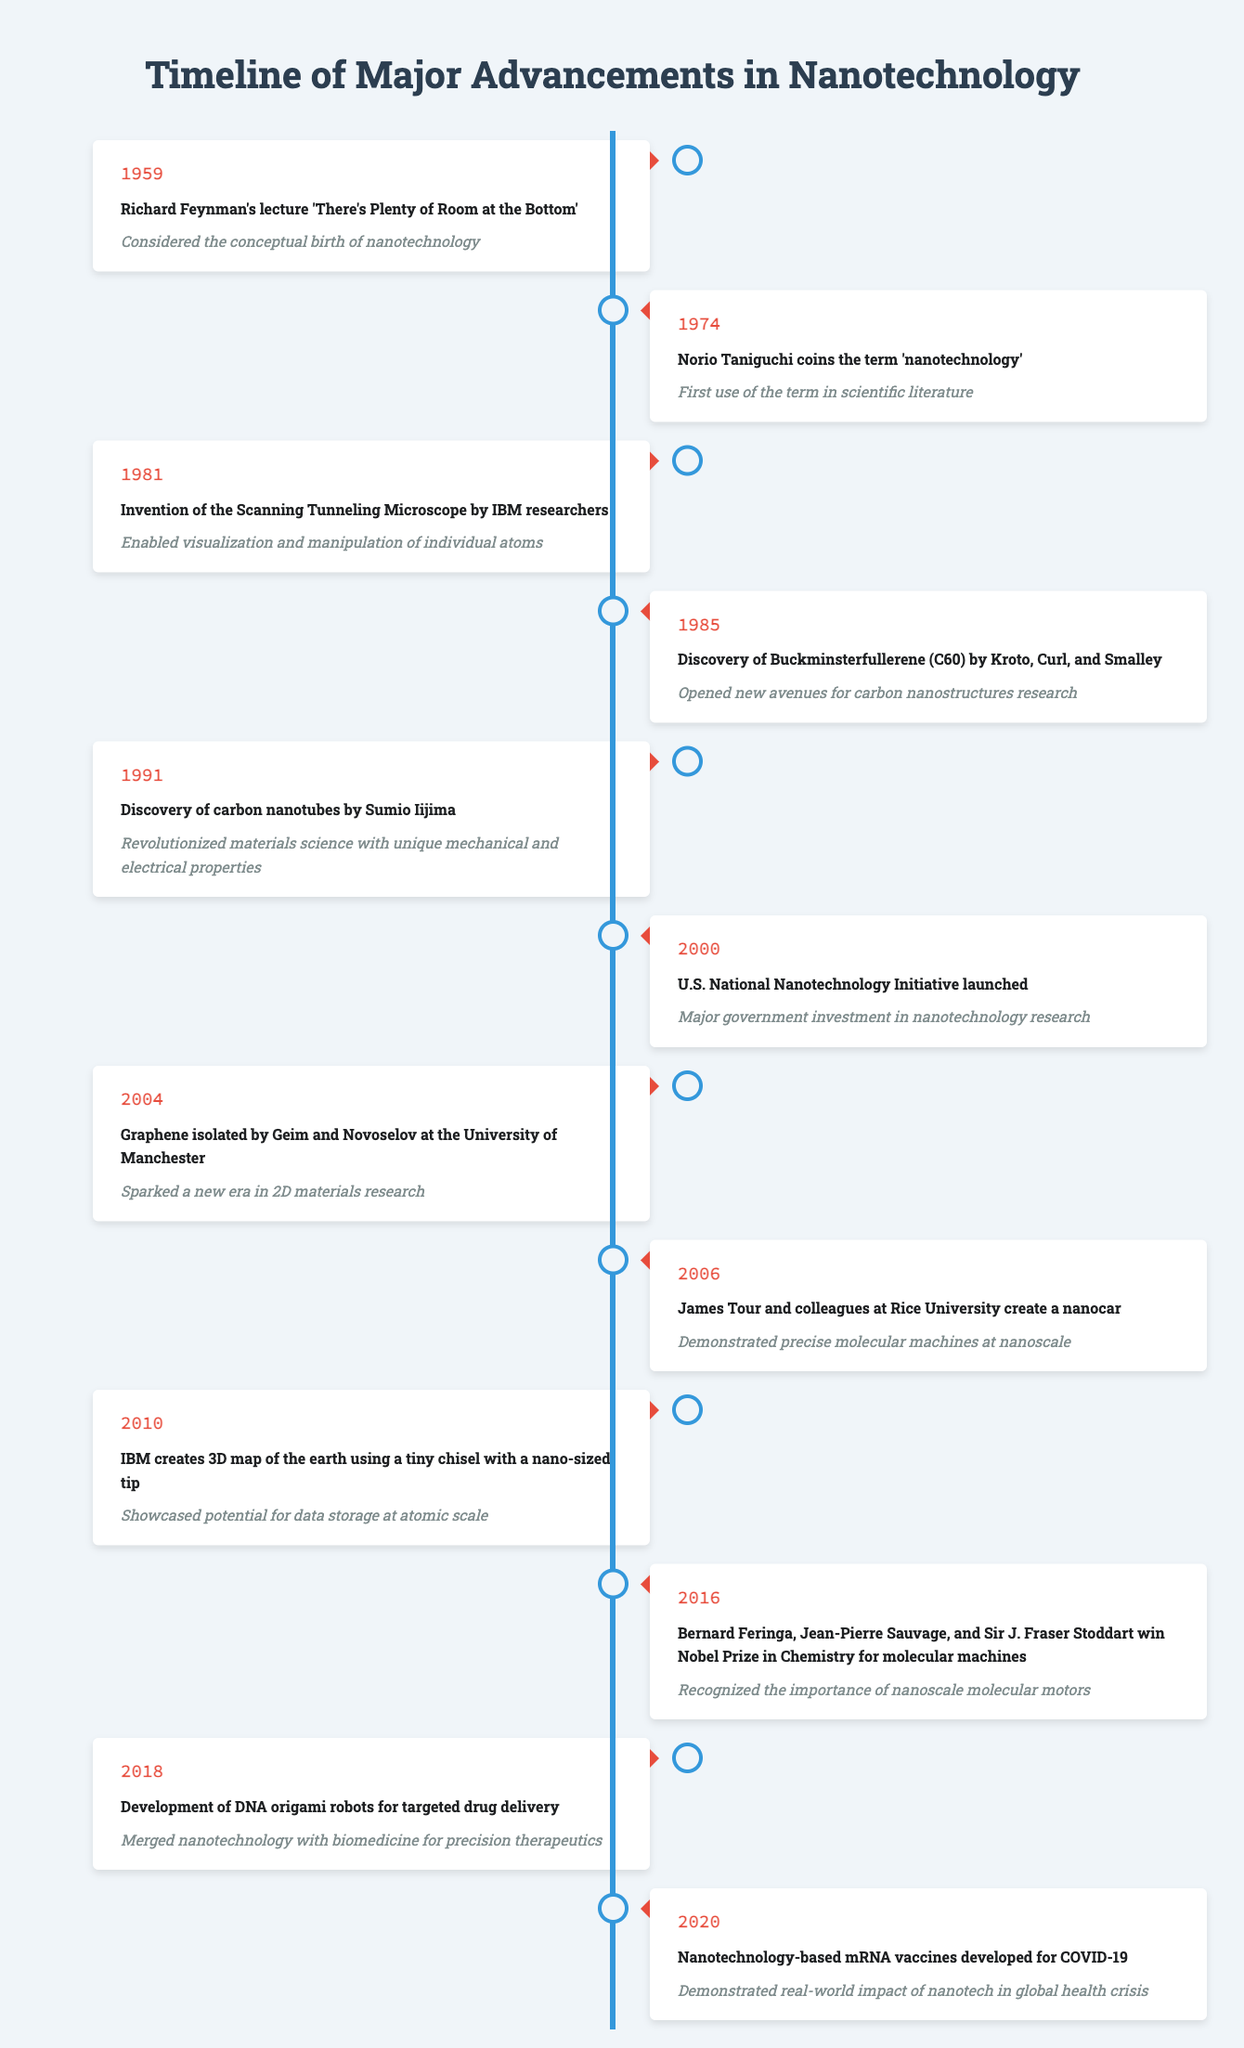What year did Richard Feynman give his lecture on nanotechnology? The table indicates that Richard Feynman's lecture titled "There's Plenty of Room at the Bottom" occurred in the year 1959.
Answer: 1959 What significant event occurred in 2004 related to nanotechnology? According to the table, in 2004, graphene was isolated by Geim and Novoselov at the University of Manchester.
Answer: Graphene isolated by Geim and Novoselov How many years were there between the first mention of 'nanotechnology' and the discovery of carbon nanotubes? The first mention of 'nanotechnology' was in 1974, and carbon nanotubes were discovered in 1991. The difference is 1991 - 1974 = 17 years.
Answer: 17 years Did the U.S. National Nanotechnology Initiative launch before the discovery of DNA origami robots? The table shows that the U.S. National Nanotechnology Initiative was launched in 2000 and DNA origami robots were developed in 2018. Since 2000 is before 2018, the answer is yes.
Answer: Yes Which advancement in nanotechnology occurred in 2016, and why was it significant? The table states that in 2016, Bernard Feringa, Jean-Pierre Sauvage, and Sir J. Fraser Stoddart won the Nobel Prize in Chemistry for molecular machines. This event was significant because it recognized the importance of nanoscale molecular motors.
Answer: Nobel Prize in Chemistry for molecular machines What is the average year of the major advancements listed in the timeline? To find the average year, we sum the years: 1959 + 1974 + 1981 + 1985 + 1991 + 2000 + 2004 + 2006 + 2010 + 2016 + 2018 + 2020 = 1990 and then divide by 12 (total events): 1990 / 12 = 165.833. Rounding gives an average year of approximately 1991.
Answer: 1991 What two breakthroughs directly impacted biomedicine, according to the timeline? Referring to the table, the breakthroughs that impacted biomedicine are the development of DNA origami robots for targeted drug delivery in 2018 and the nanotechnology-based mRNA vaccines developed for COVID-19 in 2020.
Answer: DNA origami robots and mRNA vaccines How many significant events in the timeline occurred after 2000? The table lists events from the years 2004, 2006, 2010, 2016, 2018, and 2020. Counting these gives a total of 6 events after the year 2000.
Answer: 6 events Was the discovery of carbon nanotubes recognized as revolutionary for the field of materials science? Yes, the timeline states that the discovery of carbon nanotubes in 1991 revolutionized materials science due to their unique mechanical and electrical properties.
Answer: Yes 